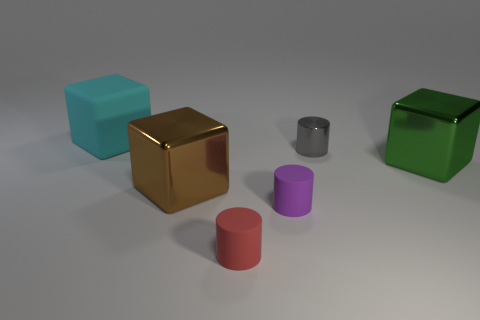There is a tiny purple object that is made of the same material as the big cyan cube; what is its shape? cylinder 